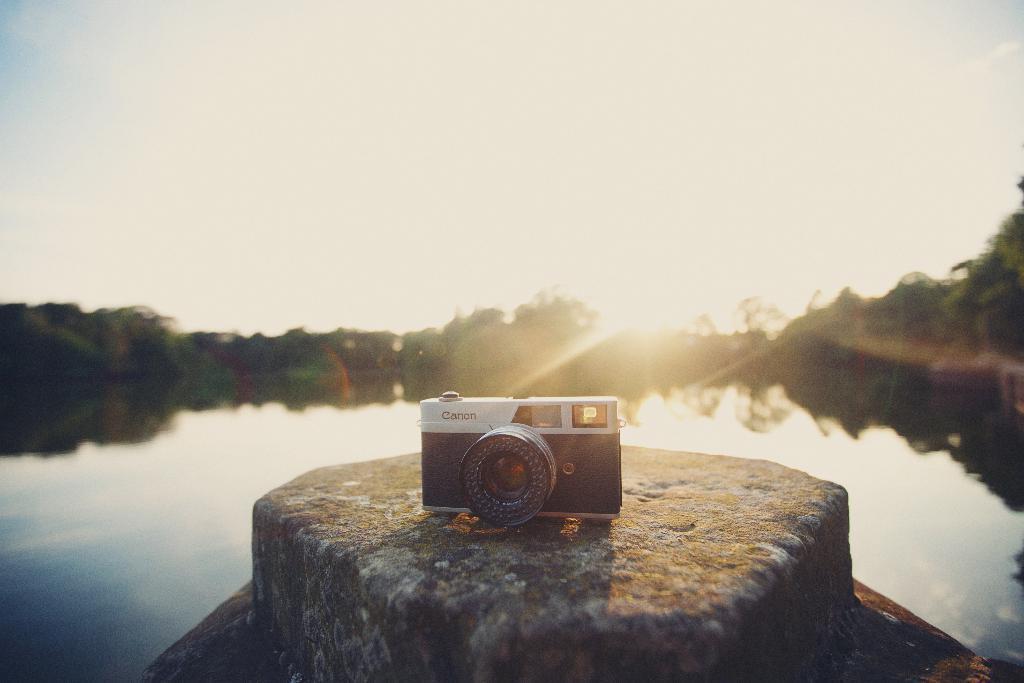Can you describe this image briefly? In this image I can see a huge rock and on it I can see a camera which is white and black in color. In the background I can see the water, few trees, the sky and the sun. 